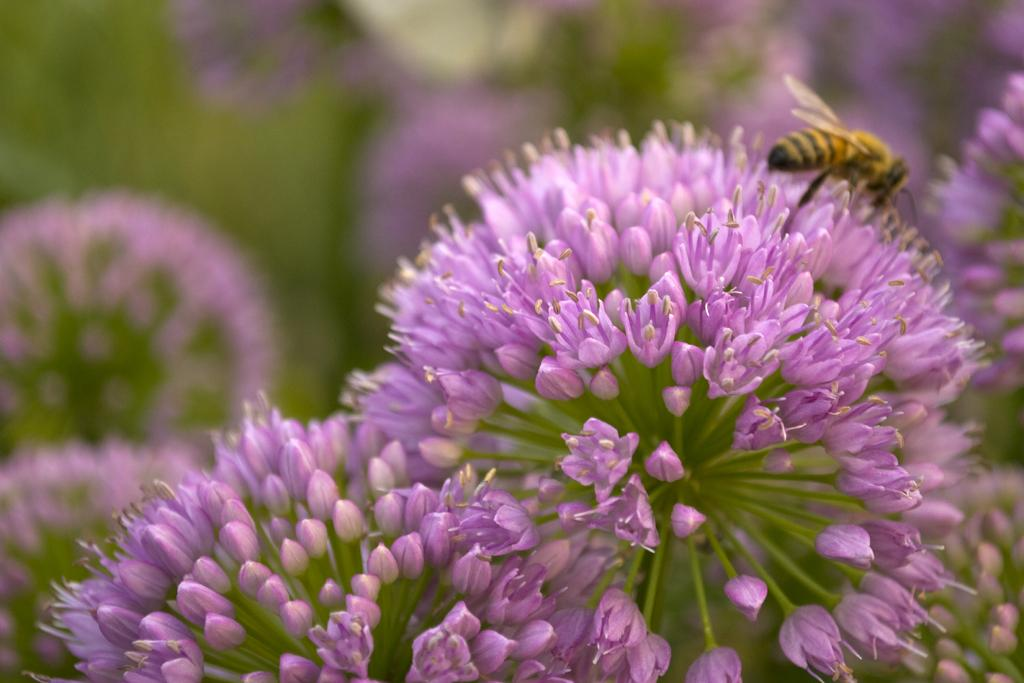What is the main subject of the image? The main subject of the image is many flowers. Can you describe the flowers in the image? There are many flowers in the middle of the image. Is there anything else present in the image besides the flowers? Yes, there is a honey bee on one of the flowers. What color is the coat worn by the honey bee in the image? Honey bees do not wear coats, and there is no coat present in the image. 